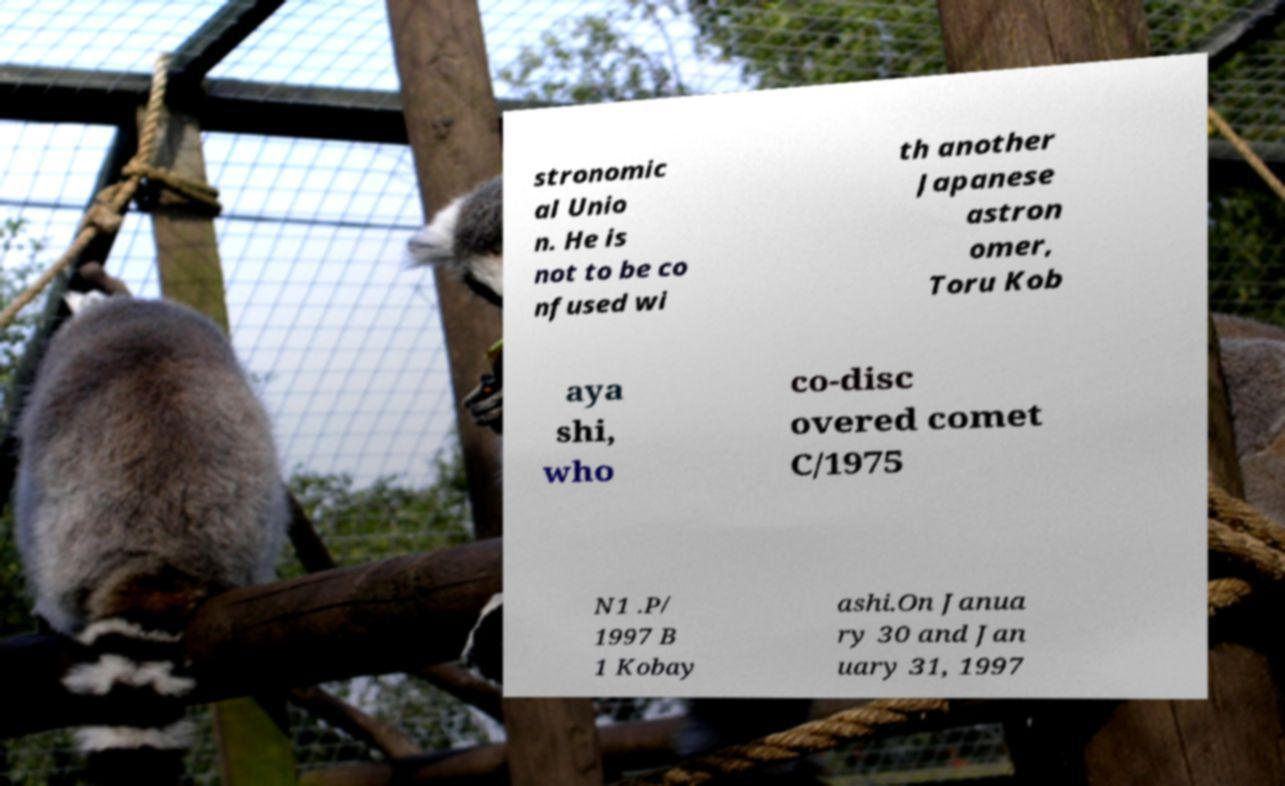What messages or text are displayed in this image? I need them in a readable, typed format. stronomic al Unio n. He is not to be co nfused wi th another Japanese astron omer, Toru Kob aya shi, who co-disc overed comet C/1975 N1 .P/ 1997 B 1 Kobay ashi.On Janua ry 30 and Jan uary 31, 1997 